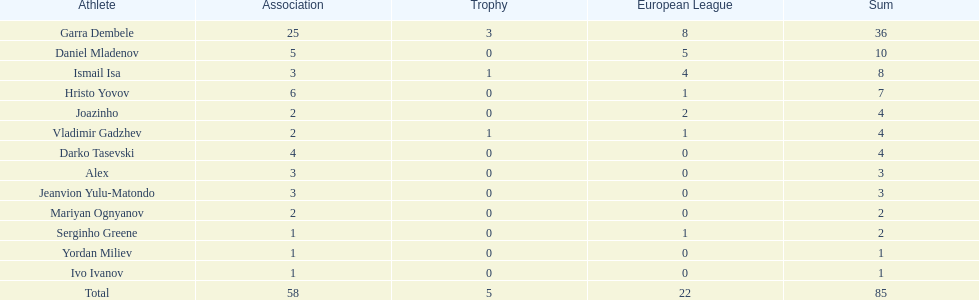Which players have at least 4 in the europa league? Garra Dembele, Daniel Mladenov, Ismail Isa. 